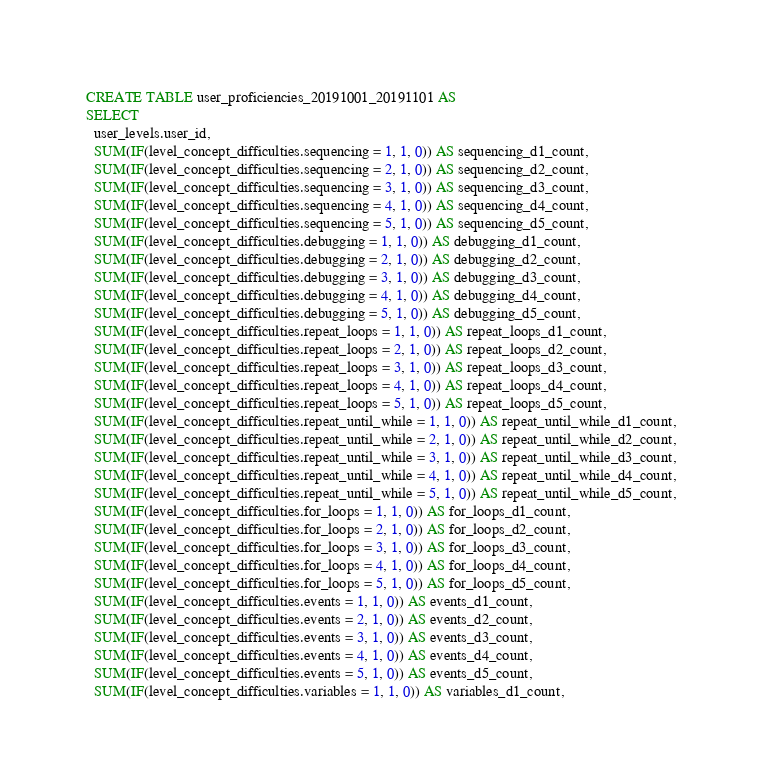<code> <loc_0><loc_0><loc_500><loc_500><_SQL_>CREATE TABLE user_proficiencies_20191001_20191101 AS
SELECT
  user_levels.user_id,
  SUM(IF(level_concept_difficulties.sequencing = 1, 1, 0)) AS sequencing_d1_count,
  SUM(IF(level_concept_difficulties.sequencing = 2, 1, 0)) AS sequencing_d2_count,
  SUM(IF(level_concept_difficulties.sequencing = 3, 1, 0)) AS sequencing_d3_count,
  SUM(IF(level_concept_difficulties.sequencing = 4, 1, 0)) AS sequencing_d4_count,
  SUM(IF(level_concept_difficulties.sequencing = 5, 1, 0)) AS sequencing_d5_count,
  SUM(IF(level_concept_difficulties.debugging = 1, 1, 0)) AS debugging_d1_count,
  SUM(IF(level_concept_difficulties.debugging = 2, 1, 0)) AS debugging_d2_count,
  SUM(IF(level_concept_difficulties.debugging = 3, 1, 0)) AS debugging_d3_count,
  SUM(IF(level_concept_difficulties.debugging = 4, 1, 0)) AS debugging_d4_count,
  SUM(IF(level_concept_difficulties.debugging = 5, 1, 0)) AS debugging_d5_count,
  SUM(IF(level_concept_difficulties.repeat_loops = 1, 1, 0)) AS repeat_loops_d1_count,
  SUM(IF(level_concept_difficulties.repeat_loops = 2, 1, 0)) AS repeat_loops_d2_count,
  SUM(IF(level_concept_difficulties.repeat_loops = 3, 1, 0)) AS repeat_loops_d3_count,
  SUM(IF(level_concept_difficulties.repeat_loops = 4, 1, 0)) AS repeat_loops_d4_count,
  SUM(IF(level_concept_difficulties.repeat_loops = 5, 1, 0)) AS repeat_loops_d5_count,
  SUM(IF(level_concept_difficulties.repeat_until_while = 1, 1, 0)) AS repeat_until_while_d1_count,
  SUM(IF(level_concept_difficulties.repeat_until_while = 2, 1, 0)) AS repeat_until_while_d2_count,
  SUM(IF(level_concept_difficulties.repeat_until_while = 3, 1, 0)) AS repeat_until_while_d3_count,
  SUM(IF(level_concept_difficulties.repeat_until_while = 4, 1, 0)) AS repeat_until_while_d4_count,
  SUM(IF(level_concept_difficulties.repeat_until_while = 5, 1, 0)) AS repeat_until_while_d5_count,
  SUM(IF(level_concept_difficulties.for_loops = 1, 1, 0)) AS for_loops_d1_count,
  SUM(IF(level_concept_difficulties.for_loops = 2, 1, 0)) AS for_loops_d2_count,
  SUM(IF(level_concept_difficulties.for_loops = 3, 1, 0)) AS for_loops_d3_count,
  SUM(IF(level_concept_difficulties.for_loops = 4, 1, 0)) AS for_loops_d4_count,
  SUM(IF(level_concept_difficulties.for_loops = 5, 1, 0)) AS for_loops_d5_count,
  SUM(IF(level_concept_difficulties.events = 1, 1, 0)) AS events_d1_count,
  SUM(IF(level_concept_difficulties.events = 2, 1, 0)) AS events_d2_count,
  SUM(IF(level_concept_difficulties.events = 3, 1, 0)) AS events_d3_count,
  SUM(IF(level_concept_difficulties.events = 4, 1, 0)) AS events_d4_count,
  SUM(IF(level_concept_difficulties.events = 5, 1, 0)) AS events_d5_count,
  SUM(IF(level_concept_difficulties.variables = 1, 1, 0)) AS variables_d1_count,</code> 